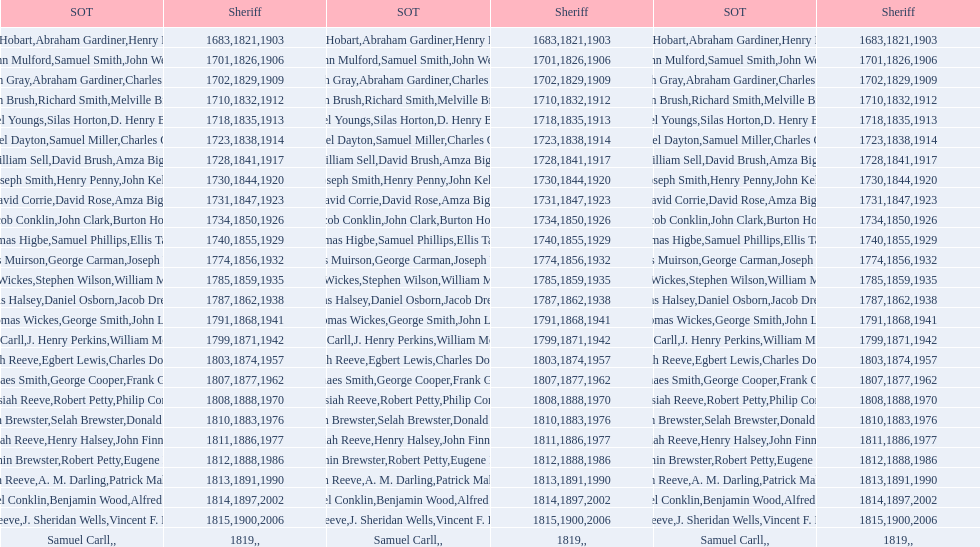What is the number of sheriff's with the last name smith? 5. 